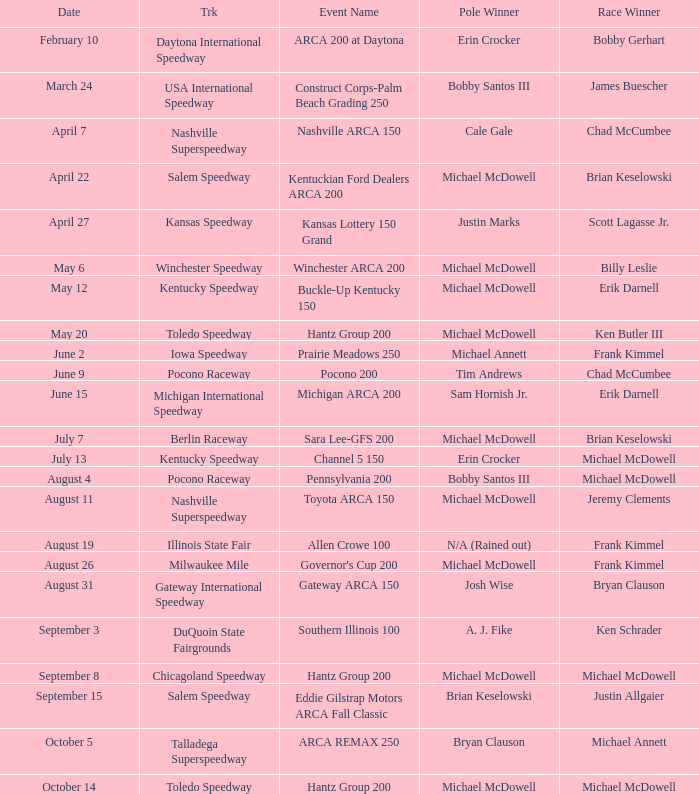Tell me the track for june 9 Pocono Raceway. 